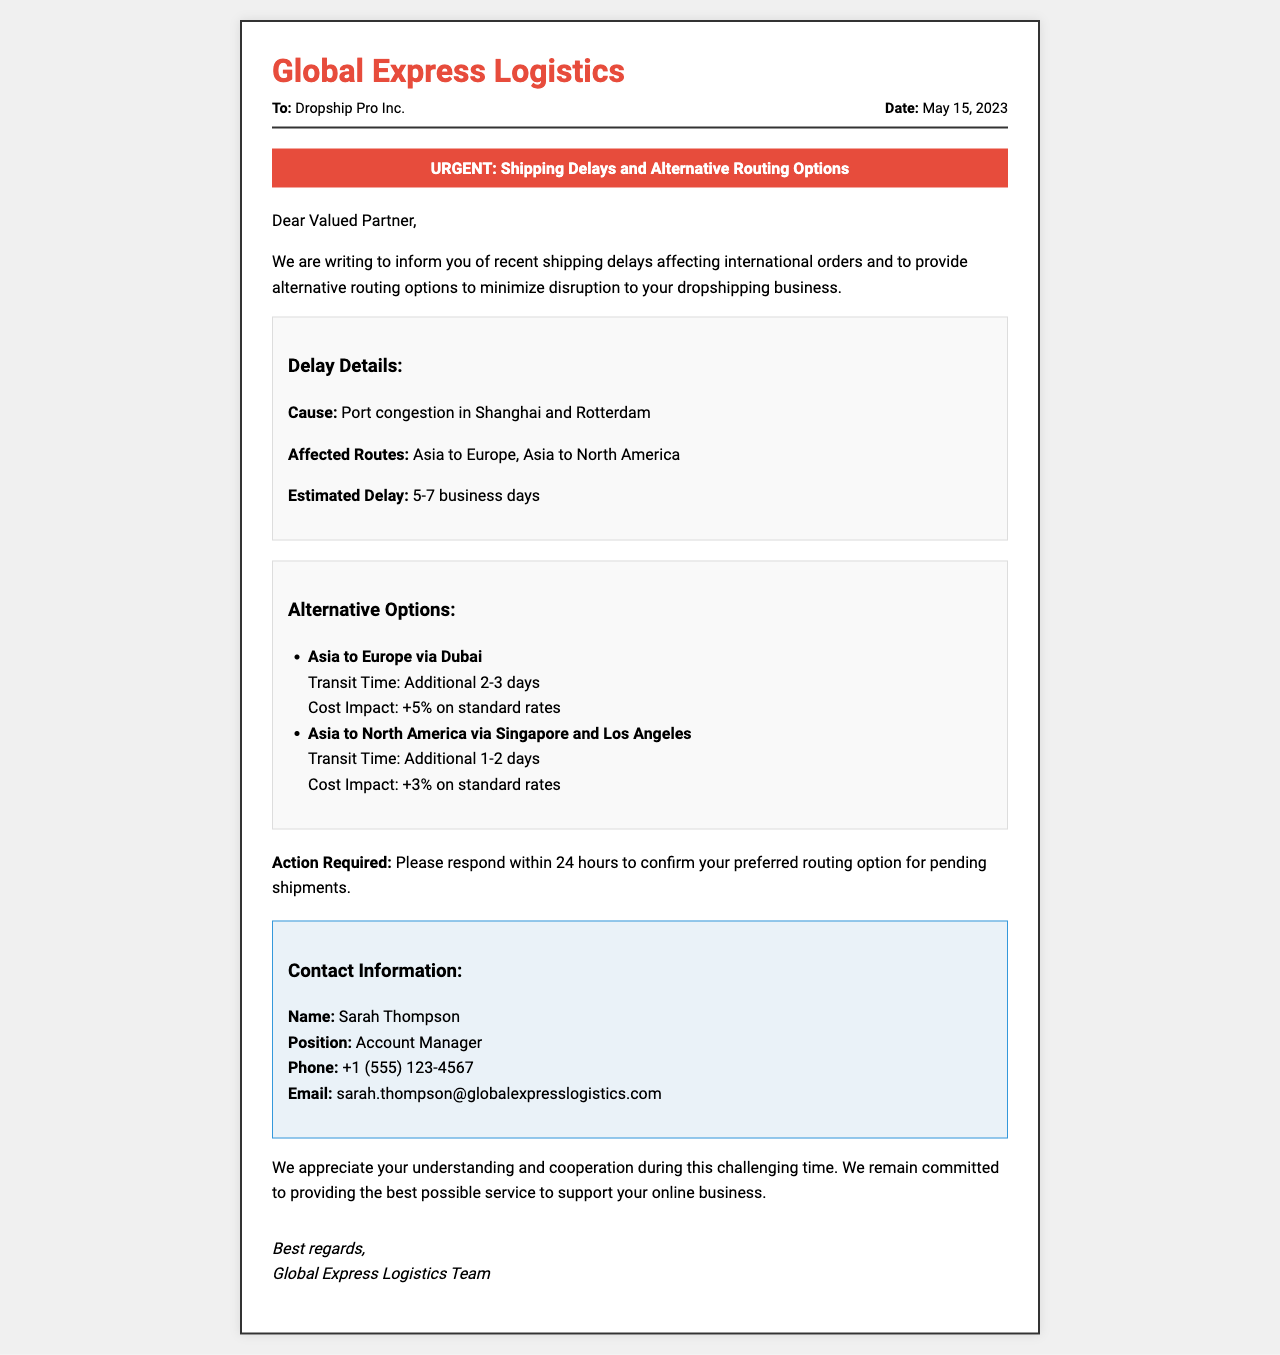What is the date of the fax? The date is mentioned in the header section of the fax document as May 15, 2023.
Answer: May 15, 2023 Who should respond to confirm the routing option? The contact information section specifies Sarah Thompson as the person to respond to.
Answer: Sarah Thompson What is the estimated delay in shipping? The estimated delay is provided in the delay details section of the fax.
Answer: 5-7 business days What is the additional transit time for Asia to Europe via Dubai? The alternative options section lists the transit time for this route as an additional 2-3 days.
Answer: Additional 2-3 days What is the cost impact for Asia to North America routing? The cost impact is specified in the alternative options section for the Asia to North America route.
Answer: +3% on standard rates What is causing the shipping delays? The cause of the shipping delays is mentioned in the delay details section of the fax.
Answer: Port congestion What should the recipient do in response to this fax? The action required is clearly stated in the content portion of the document.
Answer: Confirm preferred routing option Which company sent the fax? The sender's name is located at the top of the document, specifically in the header.
Answer: Global Express Logistics What is the contact phone number provided? The contact phone number is listed in the contact information section of the fax.
Answer: +1 (555) 123-4567 